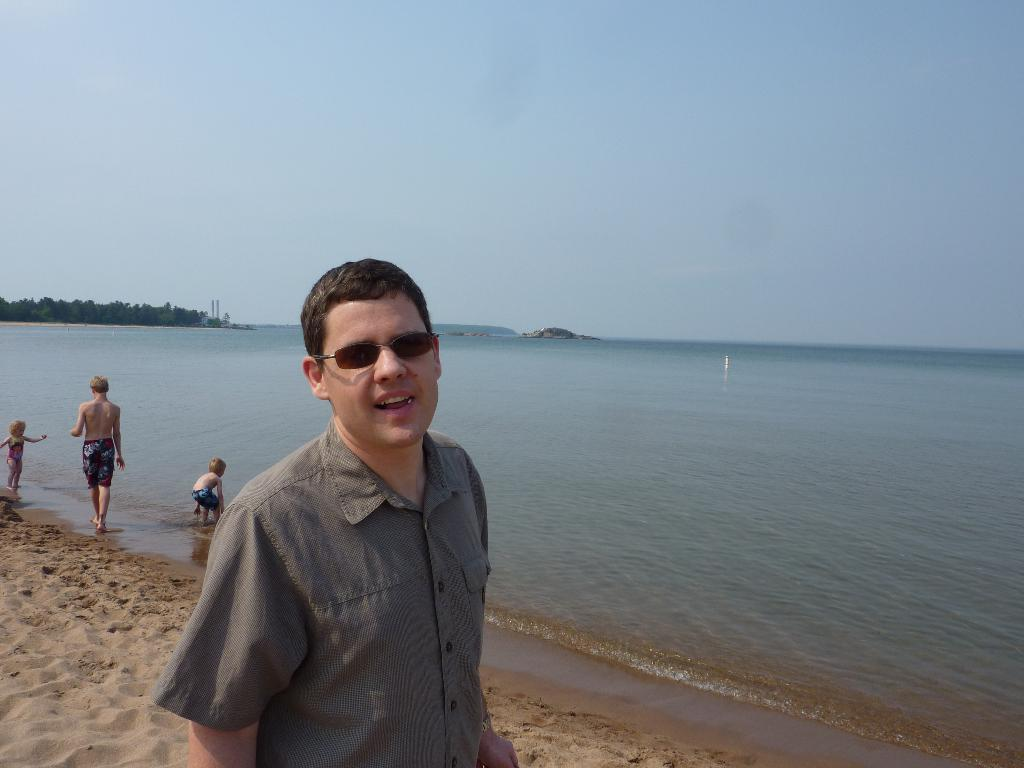Who or what can be seen in the image? There are people in the image. What type of terrain is visible in the image? There is sand and water in the image. What can be seen in the background of the image? There are trees in the background of the image. What is visible at the top of the image? The sky is visible at the top of the image. What type of lip can be seen on the people in the image? There is no mention of any lip or lips on the people in the image. 